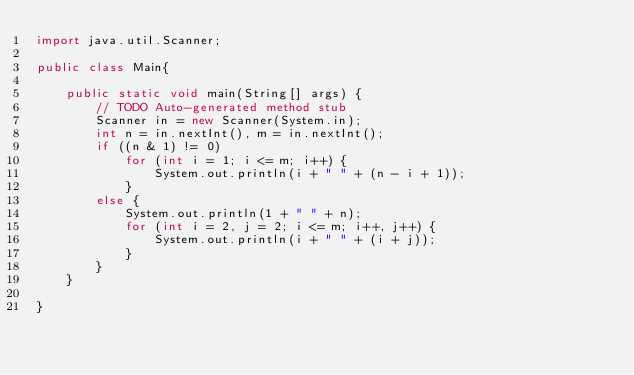Convert code to text. <code><loc_0><loc_0><loc_500><loc_500><_Java_>import java.util.Scanner;

public class Main{

    public static void main(String[] args) {
        // TODO Auto-generated method stub
        Scanner in = new Scanner(System.in);
        int n = in.nextInt(), m = in.nextInt();
        if ((n & 1) != 0)
            for (int i = 1; i <= m; i++) {
                System.out.println(i + " " + (n - i + 1));
            }
        else {
            System.out.println(1 + " " + n);
            for (int i = 2, j = 2; i <= m; i++, j++) {
                System.out.println(i + " " + (i + j));
            }
        }
    }

}
</code> 